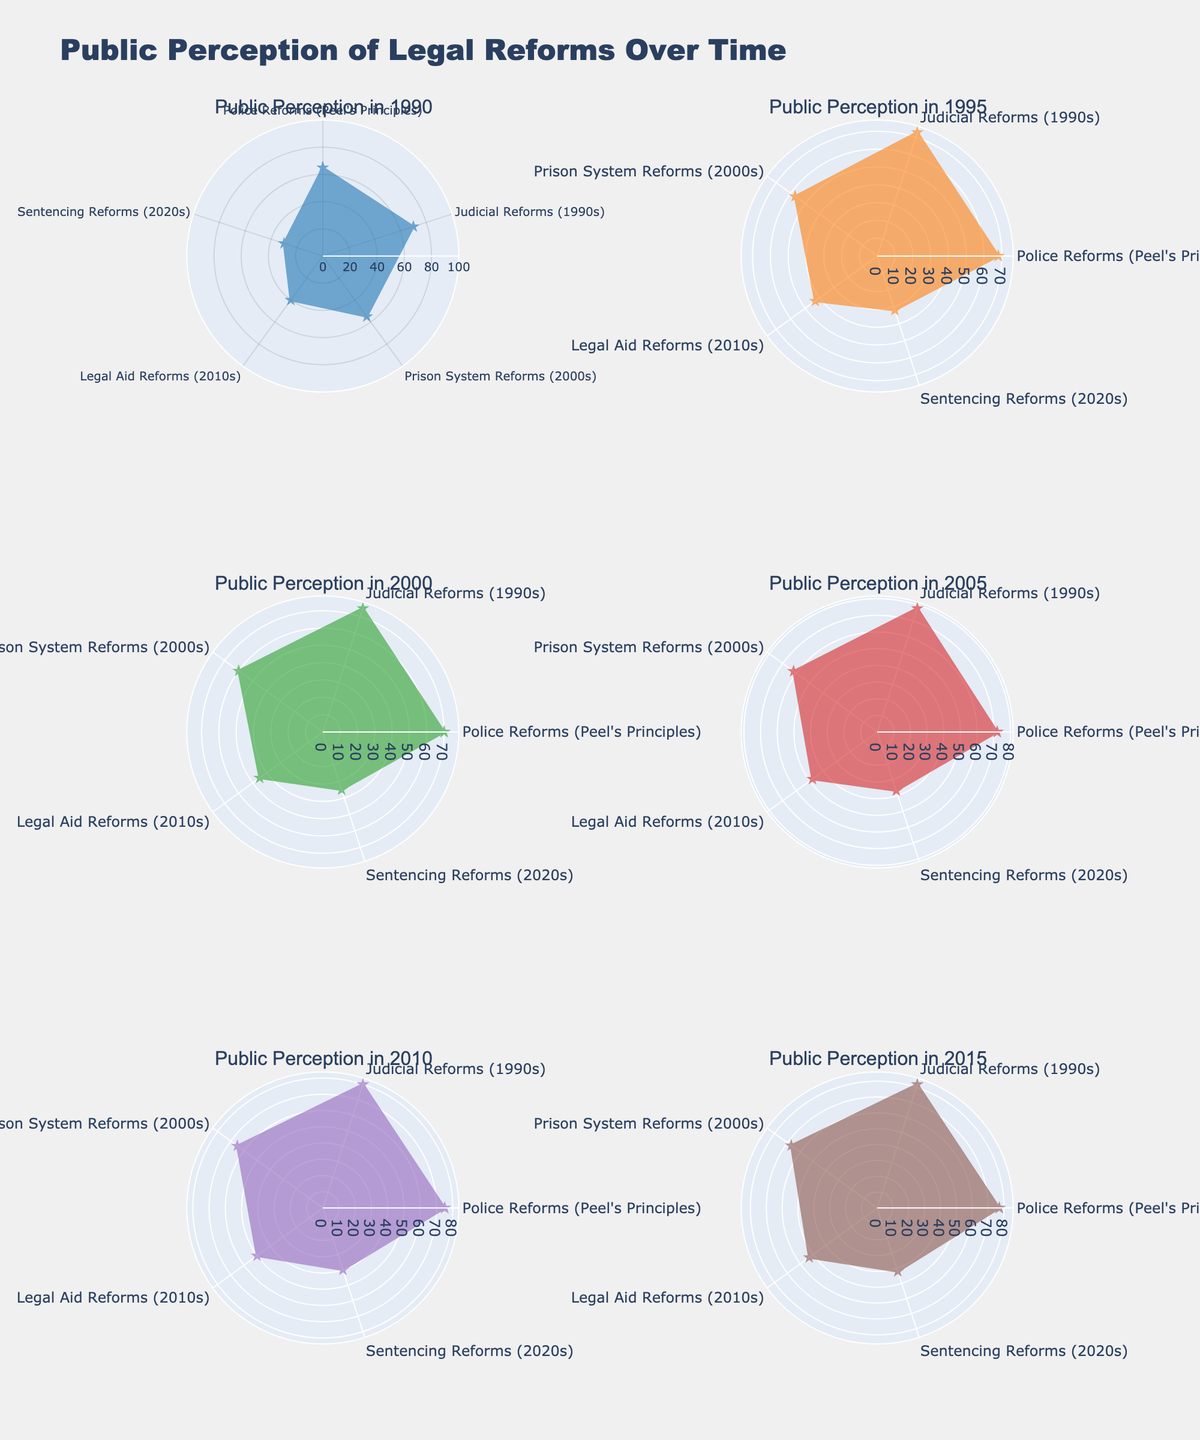What is the range of years shown in the figures? The subplot titles indicate the years for each radar chart. The years indicated are 1990, 1995, 2000, 2005, 2010, and 2015. Thus, the range of years is from 1990 to 2015.
Answer: 1990 to 2015 Which year has the highest public perception score for 'Police Reforms (Peel's Principles)'? To find this, observe the blue-colored section of the radar charts in each subplot. The highest score, 77, is seen in the year 2015.
Answer: 2015 In which year do 'Legal Aid Reforms (2010s)' and 'Sentencing Reforms (2020s)' both have the lowest values? Referring to the subplots from 1990 to 2015, check the values for both 'Legal Aid Reforms (2010s)' and 'Sentencing Reforms (2020s)'. They both have the lowest values in the year 1990, which are 40 and 30 respectively.
Answer: 1990 What is the difference in public perception for 'Prison System Reforms (2000s)' between 1990 and 2015? In 1990, 'Prison System Reforms (2000s)' had a score of 55. In 2015, the score was 67. The difference is 67 - 55 = 12.
Answer: 12 Which reform category shows the largest increase in public perception from 1990 to 2015? To find this, calculate the change for each category: 
- 'Police Reforms (Peel's Principles)': 77 - 65 = 12
- 'Judicial Reforms (1990s)': 82 - 70 = 12
- 'Prison System Reforms (2000s)': 67 - 55 = 12
- 'Legal Aid Reforms (2010s)': 53 - 40 = 13
- 'Sentencing Reforms (2020s)': 42 - 30 = 12
The largest increase is in 'Legal Aid Reforms (2010s)' with an increase of 13.
Answer: Legal Aid Reforms (2010s) Which reform shows the closest values throughout the years among 'Police Reforms (Peel's Principles)' and 'Judicial Reforms (1990s)'? By observing the radar charts, 'Police Reforms (Peel's Principles)' and 'Judicial Reforms (1990s)' have closely similar values, all with a difference of around just 2 or 3 in each year.
Answer: Police Reforms (Peel's Principles) and Judicial Reforms (1990s) What is the average public perception score for 'Sentencing Reforms (2020s)' across the years shown in the plot? To find the average, sum the scores and divide by the number of years:
(30 + 32 + 35 + 37 + 40 + 42) / 6 = 216 / 6 = 36.
Answer: 36 Which year shows the largest disparity between 'Police Reforms (Peel's Principles)' and 'Judicial Reforms (1990s)'? Checking each subplot, the largest disparity is in 2015 with 'Judicial Reforms (1990s)' at 82 and 'Police Reforms (Peel's Principles)' at 77, making a difference of 5.
Answer: 2015 